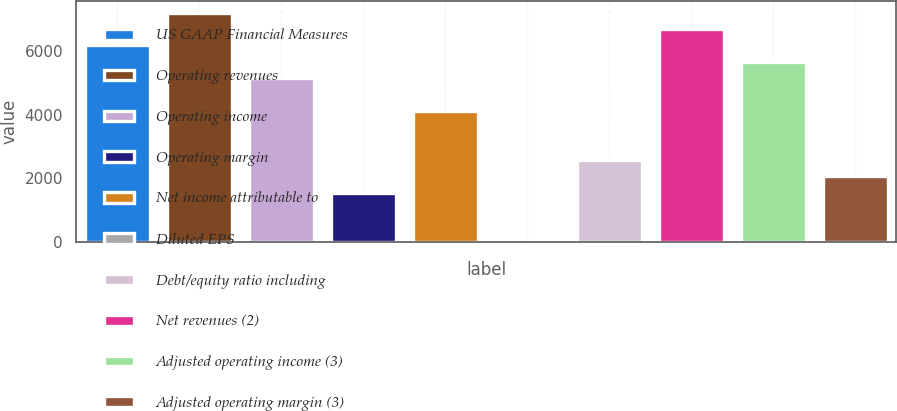Convert chart. <chart><loc_0><loc_0><loc_500><loc_500><bar_chart><fcel>US GAAP Financial Measures<fcel>Operating revenues<fcel>Operating income<fcel>Operating margin<fcel>Net income attributable to<fcel>Diluted EPS<fcel>Debt/equity ratio including<fcel>Net revenues (2)<fcel>Adjusted operating income (3)<fcel>Adjusted operating margin (3)<nl><fcel>6176.03<fcel>7204.99<fcel>5147.07<fcel>1545.71<fcel>4118.11<fcel>2.27<fcel>2574.67<fcel>6690.51<fcel>5661.55<fcel>2060.19<nl></chart> 